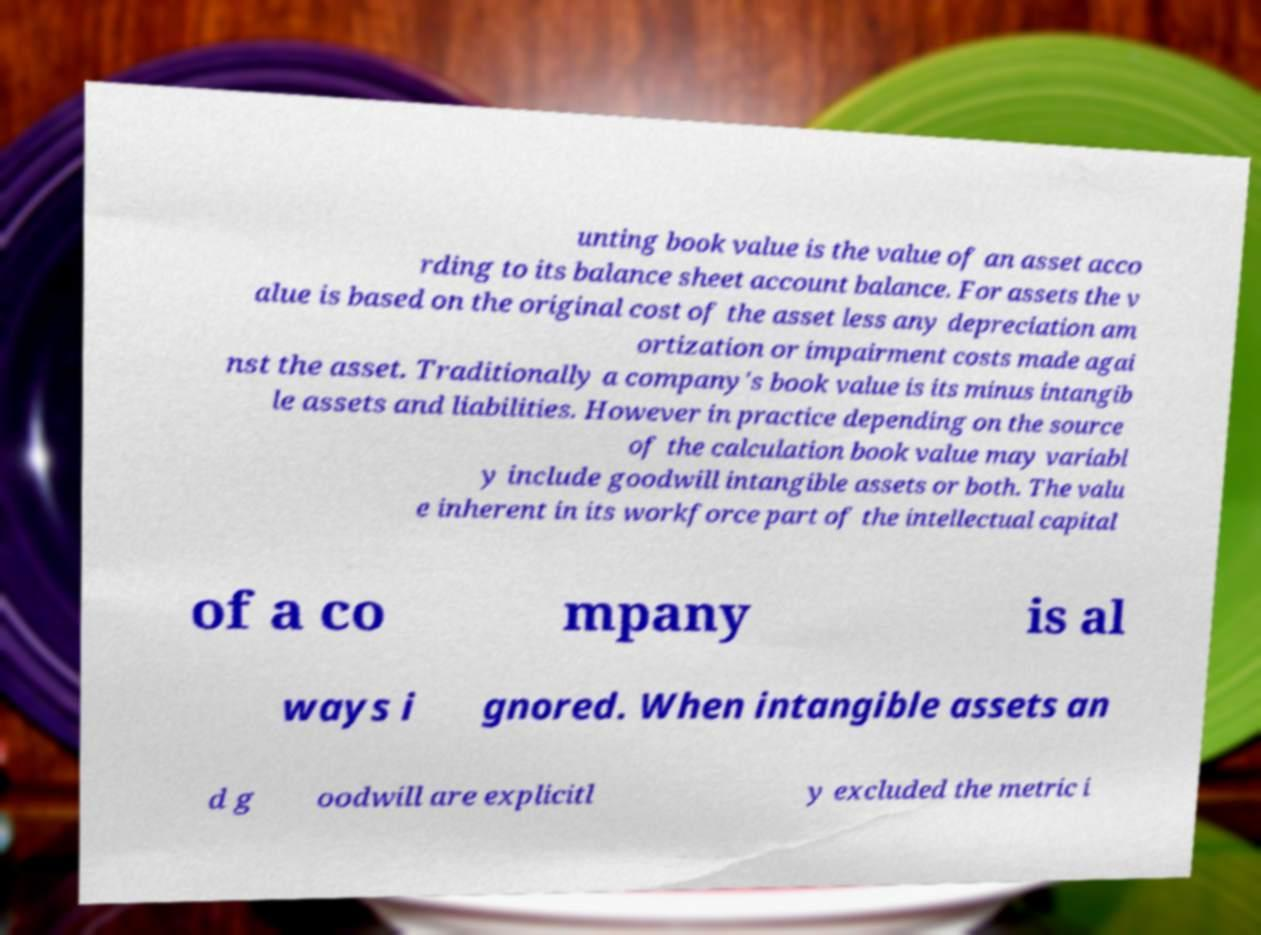Can you accurately transcribe the text from the provided image for me? unting book value is the value of an asset acco rding to its balance sheet account balance. For assets the v alue is based on the original cost of the asset less any depreciation am ortization or impairment costs made agai nst the asset. Traditionally a company's book value is its minus intangib le assets and liabilities. However in practice depending on the source of the calculation book value may variabl y include goodwill intangible assets or both. The valu e inherent in its workforce part of the intellectual capital of a co mpany is al ways i gnored. When intangible assets an d g oodwill are explicitl y excluded the metric i 